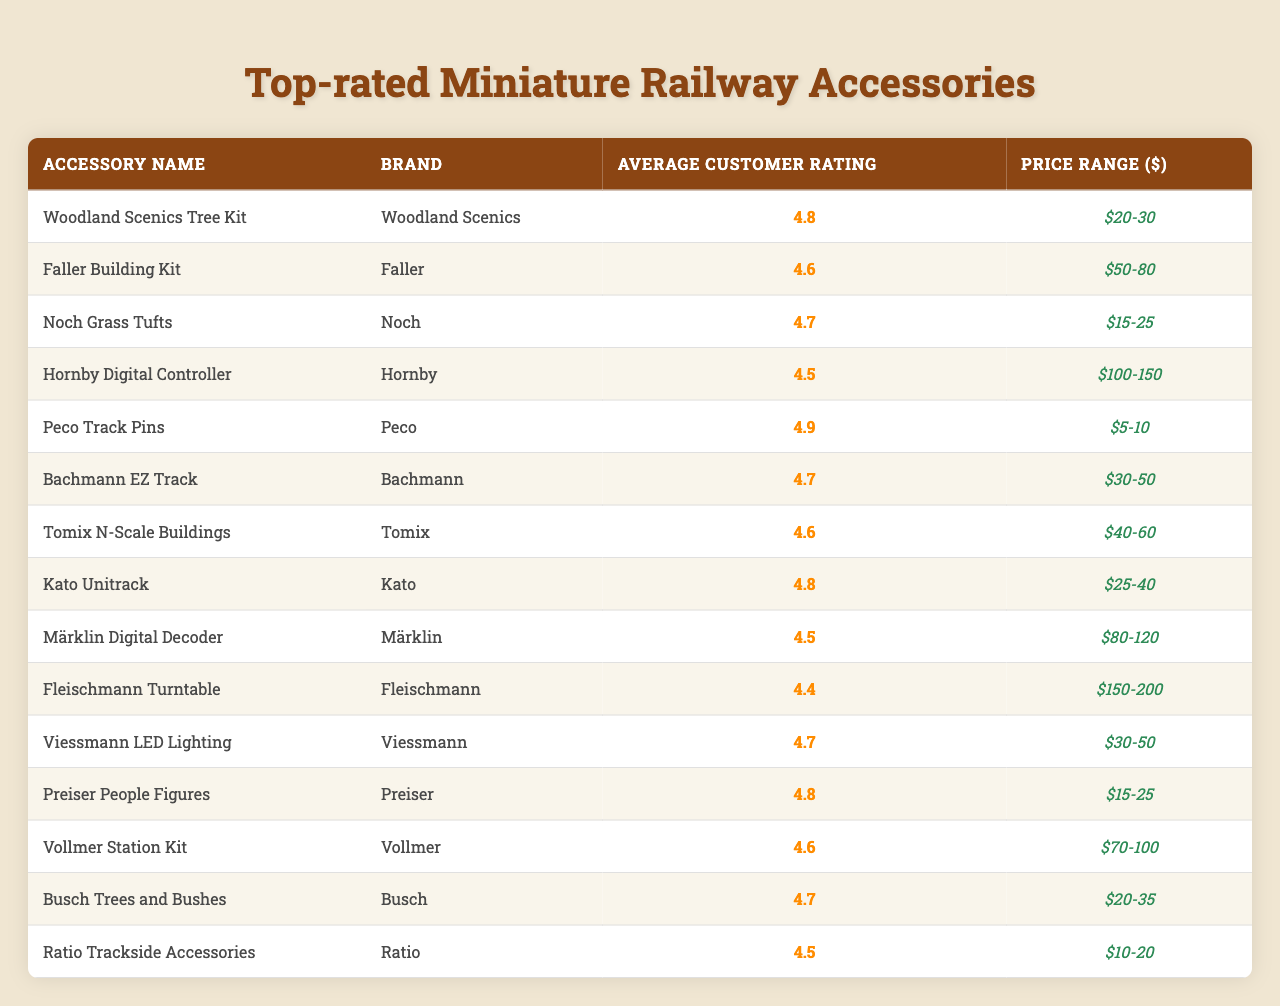What is the highest average customer rating among the accessories? The highest average customer rating listed in the table is 4.9, which corresponds to the Peco Track Pins.
Answer: 4.9 How many accessories have an average customer rating of 4.6 or higher? There are 10 accessories in the table with an average rating of 4.6 or higher: Woodland Scenics Tree Kit, Noch Grass Tufts, Bachmann EZ Track, Kato Unitrack, Preiser People Figures, Faller Building Kit, Tomix N-Scale Buildings, Vollmer Station Kit, Busch Trees and Bushes, and Peco Track Pins.
Answer: 10 Is the Hornby Digital Controller more expensive than the Fleischmann Turntable? Yes, the Hornby Digital Controller has a price range of $100-150, while the Fleischmann Turntable is priced between $150-200.
Answer: No What is the price range of the accessory with the second highest rating? The accessory with the second highest rating of 4.8 is the Kato Unitrack, which has a price range of $25-40.
Answer: $25-40 Which accessory has the lowest average customer rating, and what is that rating? The accessory with the lowest average customer rating is the Fleischmann Turntable, with a rating of 4.4.
Answer: 4.4 How does the average rating of the Faller Building Kit compare to that of the Peco Track Pins? The Faller Building Kit has an average customer rating of 4.6, while the Peco Track Pins have a higher rating of 4.9, making the Peco Track Pins higher by 0.3 points.
Answer: 0.3 points What is the average customer rating of accessories that are priced under $30? The average customer ratings for accessories priced under $30 are 4.8 (Woodland Scenics Tree Kit), 4.7 (Noch Grass Tufts), and 4.5 (Ratio Trackside Accessories). Calculating the average: (4.8 + 4.7 + 4.5) / 3 = 4.67.
Answer: 4.67 Which brand has the most accessories listed in the table? The brand with the most accessories listed is "Woodland Scenics," but there is only one accessory from each brand represented here.
Answer: 1 What is the average customer rating for all accessories in the table? To find the average customer rating for all accessories, we first sum all the ratings: 4.8 + 4.6 + 4.7 + 4.5 + 4.9 + 4.7 + 4.6 + 4.8 + 4.5 + 4.4 + 4.7 + 4.8 + 4.6 + 4.7 + 4.5 = 69.6. There are 15 accessories; hence the average is 69.6 / 15 = 4.64.
Answer: 4.64 Are there any accessories in the table priced below $10? No, the lowest price range among the accessories is $5-10 for Peco Track Pins, and there are no accessories priced below $5.
Answer: No 